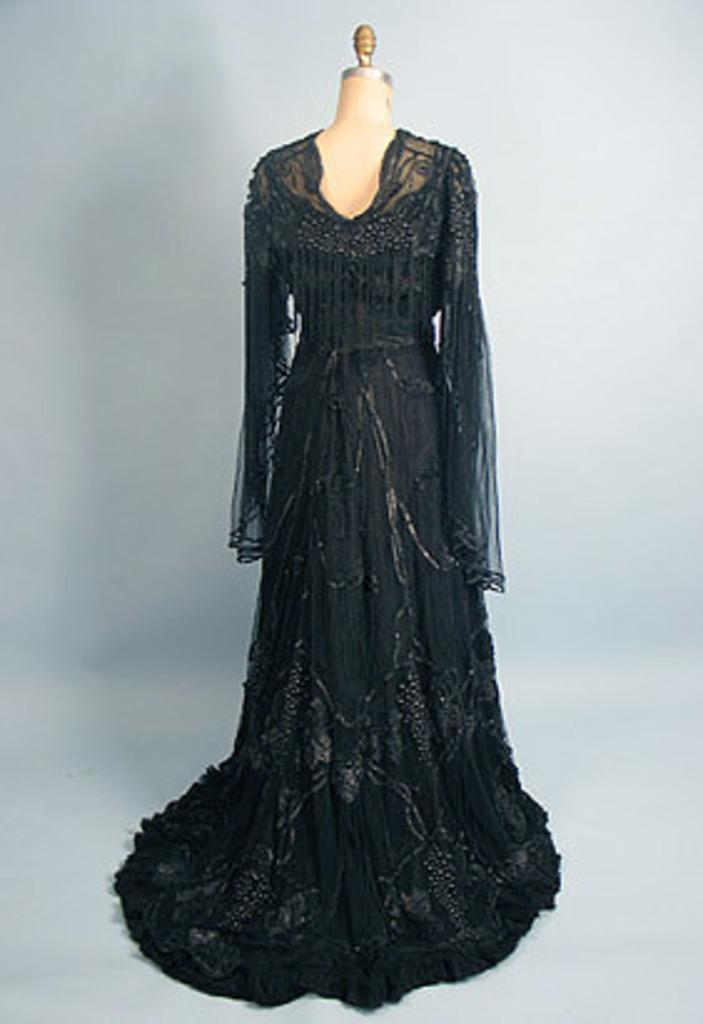What is placed on the mannequin in the image? There is a cloth on a mannequin in the image. What color is the cloth? The cloth is black in color. What type of slope is visible in the image? There is no slope present in the image; it features a cloth on a mannequin. Is there a throne visible in the image? There is no throne present in the image; it features a cloth on a mannequin. 